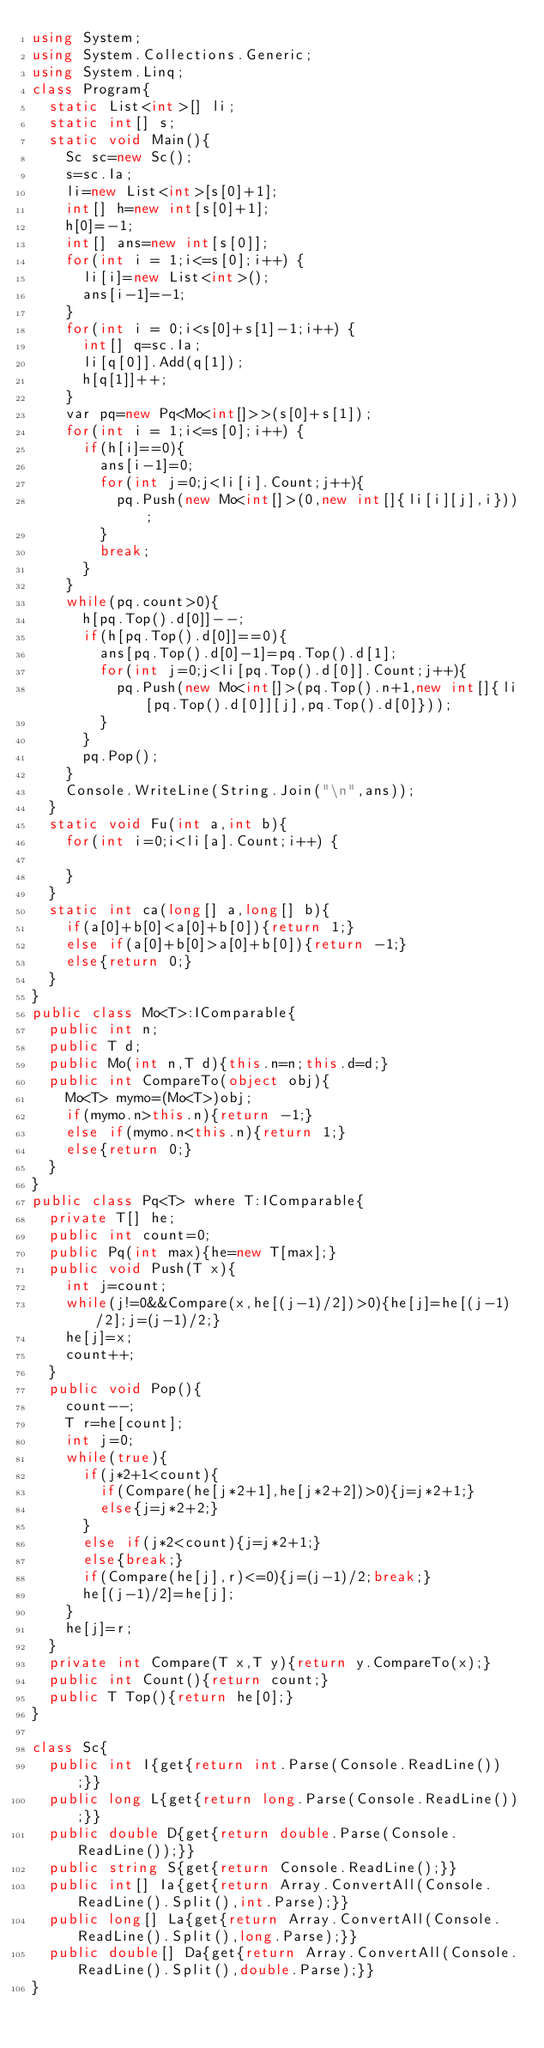<code> <loc_0><loc_0><loc_500><loc_500><_C#_>using System;
using System.Collections.Generic;
using System.Linq;
class Program{
	static List<int>[] li;
	static int[] s;
	static void Main(){
		Sc sc=new Sc();
		s=sc.Ia;
		li=new List<int>[s[0]+1];
		int[] h=new int[s[0]+1];
		h[0]=-1;
		int[] ans=new int[s[0]];
		for(int i = 1;i<=s[0];i++) {
			li[i]=new List<int>();
			ans[i-1]=-1;
		}
		for(int i = 0;i<s[0]+s[1]-1;i++) {
			int[] q=sc.Ia;
			li[q[0]].Add(q[1]);
			h[q[1]]++;
		}
		var pq=new Pq<Mo<int[]>>(s[0]+s[1]);
		for(int i = 1;i<=s[0];i++) {
			if(h[i]==0){
				ans[i-1]=0;
				for(int j=0;j<li[i].Count;j++){
					pq.Push(new Mo<int[]>(0,new int[]{li[i][j],i}));
				}
				break;
			}
		}
		while(pq.count>0){
			h[pq.Top().d[0]]--;
			if(h[pq.Top().d[0]]==0){
				ans[pq.Top().d[0]-1]=pq.Top().d[1];
				for(int j=0;j<li[pq.Top().d[0]].Count;j++){
					pq.Push(new Mo<int[]>(pq.Top().n+1,new int[]{li[pq.Top().d[0]][j],pq.Top().d[0]}));
				}
			}
			pq.Pop();
		}
		Console.WriteLine(String.Join("\n",ans));
	}
	static void Fu(int a,int b){
		for(int i=0;i<li[a].Count;i++) {
			
		}
	}
	static int ca(long[] a,long[] b){
		if(a[0]+b[0]<a[0]+b[0]){return 1;}
		else if(a[0]+b[0]>a[0]+b[0]){return -1;}
		else{return 0;}
	}
}
public class Mo<T>:IComparable{
	public int n;
	public T d;
	public Mo(int n,T d){this.n=n;this.d=d;}
	public int CompareTo(object obj){
		Mo<T> mymo=(Mo<T>)obj;
		if(mymo.n>this.n){return -1;}
		else if(mymo.n<this.n){return 1;}
		else{return 0;}
	}
}
public class Pq<T> where T:IComparable{
	private T[] he;
	public int count=0;
	public Pq(int max){he=new T[max];}
	public void Push(T x){
		int j=count;
		while(j!=0&&Compare(x,he[(j-1)/2])>0){he[j]=he[(j-1)/2];j=(j-1)/2;}
		he[j]=x;
		count++;
	}
	public void Pop(){
		count--;
		T r=he[count];
		int j=0;
		while(true){
			if(j*2+1<count){
				if(Compare(he[j*2+1],he[j*2+2])>0){j=j*2+1;}
				else{j=j*2+2;}
			}
			else if(j*2<count){j=j*2+1;}
			else{break;}
			if(Compare(he[j],r)<=0){j=(j-1)/2;break;}
			he[(j-1)/2]=he[j];
		}
		he[j]=r;
	}
	private int Compare(T x,T y){return y.CompareTo(x);}
	public int Count(){return count;}
	public T Top(){return he[0];}
}

class Sc{
	public int I{get{return int.Parse(Console.ReadLine());}}
	public long L{get{return long.Parse(Console.ReadLine());}}
	public double D{get{return double.Parse(Console.ReadLine());}}
	public string S{get{return Console.ReadLine();}}
	public int[] Ia{get{return Array.ConvertAll(Console.ReadLine().Split(),int.Parse);}}
	public long[] La{get{return Array.ConvertAll(Console.ReadLine().Split(),long.Parse);}}
	public double[] Da{get{return Array.ConvertAll(Console.ReadLine().Split(),double.Parse);}}
}</code> 